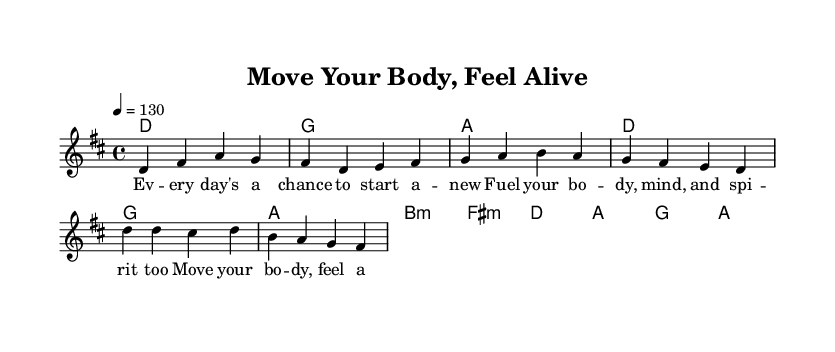What is the key signature of this music? The key signature is D major, indicated by the presence of two sharps (F# and C#). This can be determined from the global settings at the beginning of the score.
Answer: D major What is the time signature of this piece? The time signature is 4/4, as shown in the global settings at the start of the music. This indicates there are four beats per measure and each beat is a quarter note.
Answer: 4/4 What is the tempo marking for this song? The tempo marking is 130 beats per minute, specified in the global section as "4 = 130." This indicates the speed at which the piece should be played.
Answer: 130 How many measures are in the verse? The verse consists of 4 measures, which can be counted from the melody section where the verse is indicated. Each measure contains a set of notes corresponding to the lyrics.
Answer: 4 What is the pattern of the first two lines of lyrics? The first two lines of lyrics have a pattern of 8 syllables each. This can be checked by counting the syllables of “Every day's a chance to start a new” and “Fuel your body, mind, and spirit too.” Both lines maintain the same metrical structure.
Answer: 8 syllables What chords accompany the pre-chorus? The chords accompanying the pre-chorus are G, A, B minor, and F sharp minor. This can be determined by examining the harmonies section during the pre-chorus measures.
Answer: G, A, B minor, F sharp minor 